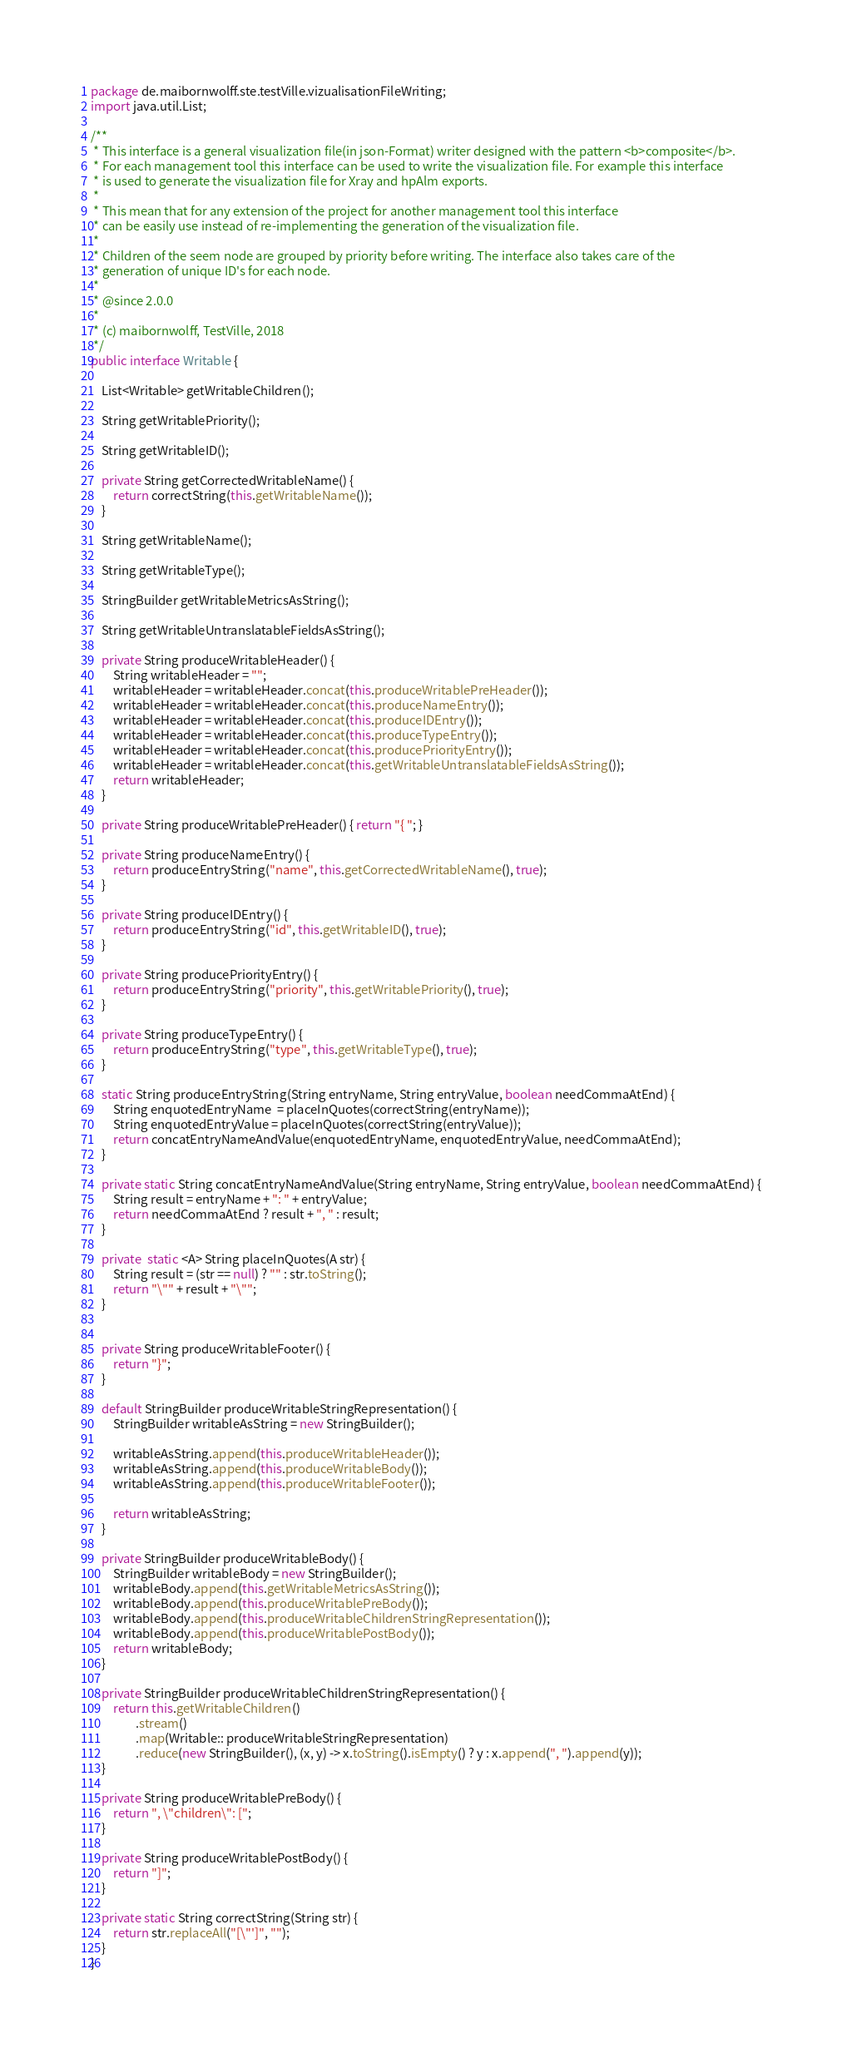<code> <loc_0><loc_0><loc_500><loc_500><_Java_>package de.maibornwolff.ste.testVille.vizualisationFileWriting;
import java.util.List;

/**
 * This interface is a general visualization file(in json-Format) writer designed with the pattern <b>composite</b>.
 * For each management tool this interface can be used to write the visualization file. For example this interface
 * is used to generate the visualization file for Xray and hpAlm exports.
 *
 * This mean that for any extension of the project for another management tool this interface
 * can be easily use instead of re-implementing the generation of the visualization file.
 *
 * Children of the seem node are grouped by priority before writing. The interface also takes care of the
 * generation of unique ID's for each node.
 *
 * @since 2.0.0
 *
 * (c) maibornwolff, TestVille, 2018
 */
public interface Writable {

    List<Writable> getWritableChildren();

    String getWritablePriority();

    String getWritableID();

    private String getCorrectedWritableName() {
        return correctString(this.getWritableName());
    }

    String getWritableName();

    String getWritableType();

    StringBuilder getWritableMetricsAsString();

    String getWritableUntranslatableFieldsAsString();

    private String produceWritableHeader() {
        String writableHeader = "";
        writableHeader = writableHeader.concat(this.produceWritablePreHeader());
        writableHeader = writableHeader.concat(this.produceNameEntry());
        writableHeader = writableHeader.concat(this.produceIDEntry());
        writableHeader = writableHeader.concat(this.produceTypeEntry());
        writableHeader = writableHeader.concat(this.producePriorityEntry());
        writableHeader = writableHeader.concat(this.getWritableUntranslatableFieldsAsString());
        return writableHeader;
    }

    private String produceWritablePreHeader() { return "{ "; }

    private String produceNameEntry() {
        return produceEntryString("name", this.getCorrectedWritableName(), true);
    }

    private String produceIDEntry() {
        return produceEntryString("id", this.getWritableID(), true);
    }

    private String producePriorityEntry() {
        return produceEntryString("priority", this.getWritablePriority(), true);
    }

    private String produceTypeEntry() {
        return produceEntryString("type", this.getWritableType(), true);
    }

    static String produceEntryString(String entryName, String entryValue, boolean needCommaAtEnd) {
        String enquotedEntryName  = placeInQuotes(correctString(entryName));
        String enquotedEntryValue = placeInQuotes(correctString(entryValue));
        return concatEntryNameAndValue(enquotedEntryName, enquotedEntryValue, needCommaAtEnd);
    }

    private static String concatEntryNameAndValue(String entryName, String entryValue, boolean needCommaAtEnd) {
        String result = entryName + ": " + entryValue;
        return needCommaAtEnd ? result + ", " : result;
    }

    private  static <A> String placeInQuotes(A str) {
        String result = (str == null) ? "" : str.toString();
        return "\"" + result + "\"";
    }


    private String produceWritableFooter() {
        return "}";
    }

    default StringBuilder produceWritableStringRepresentation() {
        StringBuilder writableAsString = new StringBuilder();

        writableAsString.append(this.produceWritableHeader());
        writableAsString.append(this.produceWritableBody());
        writableAsString.append(this.produceWritableFooter());

        return writableAsString;
    }

    private StringBuilder produceWritableBody() {
        StringBuilder writableBody = new StringBuilder();
        writableBody.append(this.getWritableMetricsAsString());
        writableBody.append(this.produceWritablePreBody());
        writableBody.append(this.produceWritableChildrenStringRepresentation());
        writableBody.append(this.produceWritablePostBody());
        return writableBody;
    }

    private StringBuilder produceWritableChildrenStringRepresentation() {
        return this.getWritableChildren()
                .stream()
                .map(Writable:: produceWritableStringRepresentation)
                .reduce(new StringBuilder(), (x, y) -> x.toString().isEmpty() ? y : x.append(", ").append(y));
    }

    private String produceWritablePreBody() {
        return ", \"children\": [";
    }

    private String produceWritablePostBody() {
        return "]";
    }

    private static String correctString(String str) {
        return str.replaceAll("[\"']", "");
    }
}</code> 